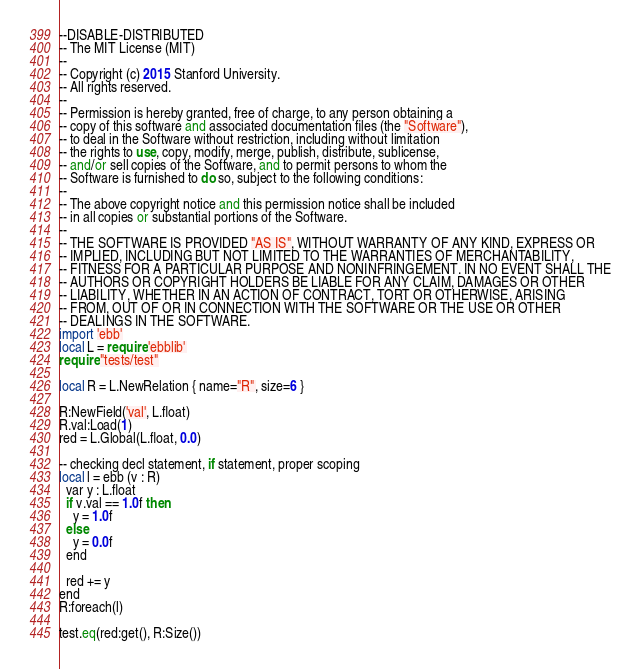Convert code to text. <code><loc_0><loc_0><loc_500><loc_500><_Perl_>--DISABLE-DISTRIBUTED
-- The MIT License (MIT)
-- 
-- Copyright (c) 2015 Stanford University.
-- All rights reserved.
-- 
-- Permission is hereby granted, free of charge, to any person obtaining a
-- copy of this software and associated documentation files (the "Software"),
-- to deal in the Software without restriction, including without limitation
-- the rights to use, copy, modify, merge, publish, distribute, sublicense,
-- and/or sell copies of the Software, and to permit persons to whom the
-- Software is furnished to do so, subject to the following conditions:
-- 
-- The above copyright notice and this permission notice shall be included
-- in all copies or substantial portions of the Software.
-- 
-- THE SOFTWARE IS PROVIDED "AS IS", WITHOUT WARRANTY OF ANY KIND, EXPRESS OR
-- IMPLIED, INCLUDING BUT NOT LIMITED TO THE WARRANTIES OF MERCHANTABILITY,
-- FITNESS FOR A PARTICULAR PURPOSE AND NONINFRINGEMENT. IN NO EVENT SHALL THE
-- AUTHORS OR COPYRIGHT HOLDERS BE LIABLE FOR ANY CLAIM, DAMAGES OR OTHER
-- LIABILITY, WHETHER IN AN ACTION OF CONTRACT, TORT OR OTHERWISE, ARISING 
-- FROM, OUT OF OR IN CONNECTION WITH THE SOFTWARE OR THE USE OR OTHER
-- DEALINGS IN THE SOFTWARE.
import 'ebb'
local L = require 'ebblib'
require "tests/test"

local R = L.NewRelation { name="R", size=6 }

R:NewField('val', L.float)
R.val:Load(1)
red = L.Global(L.float, 0.0)

-- checking decl statement, if statement, proper scoping
local l = ebb (v : R)
  var y : L.float
  if v.val == 1.0f then
    y = 1.0f
  else
    y = 0.0f
  end

  red += y
end
R:foreach(l)

test.eq(red:get(), R:Size())
</code> 